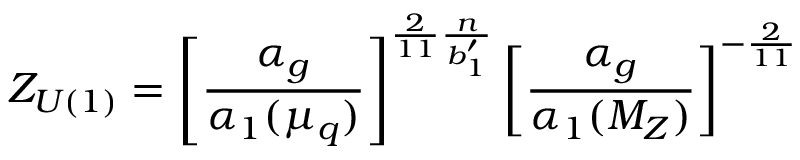<formula> <loc_0><loc_0><loc_500><loc_500>Z _ { U ( 1 ) } = \left [ \frac { \alpha _ { g } } { \alpha _ { 1 } ( \mu _ { q } ) } \right ] ^ { \frac { 2 } { 1 1 } \frac { n } { b _ { 1 } ^ { \prime } } } \left [ \frac { \alpha _ { g } } { \alpha _ { 1 } ( M _ { Z } ) } \right ] ^ { - \frac { 2 } { 1 1 } }</formula> 